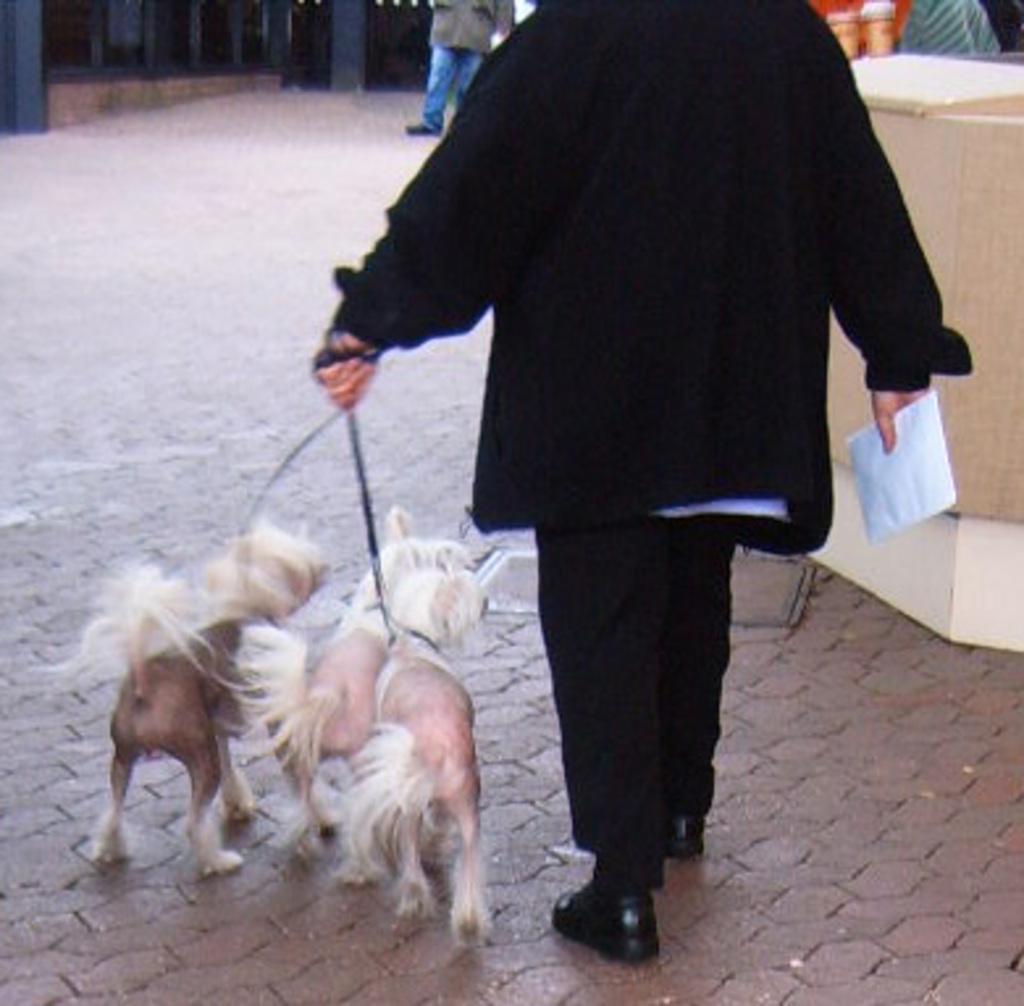How would you summarize this image in a sentence or two? In this image we can see a person holding leashes of three dogs and a paper. On the right side, we can see a wooden object. At the top we can see a person and objects. 